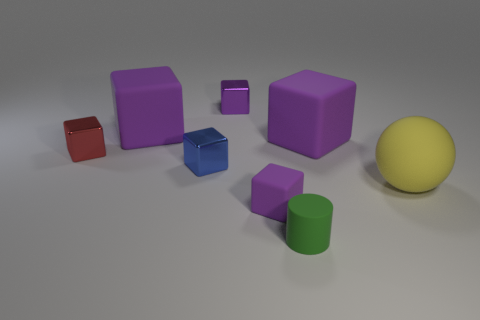There is a rubber block in front of the red metal object; does it have the same color as the big matte cube that is to the left of the matte cylinder?
Keep it short and to the point. Yes. Are there any small blue metal blocks?
Offer a very short reply. Yes. Is there a blue cube that has the same material as the red object?
Your answer should be very brief. Yes. What is the color of the tiny rubber cylinder?
Make the answer very short. Green. The tiny object that is the same color as the small matte block is what shape?
Ensure brevity in your answer.  Cube. What is the color of the rubber block that is the same size as the red object?
Your answer should be compact. Purple. How many matte things are objects or small green objects?
Keep it short and to the point. 5. What number of matte objects are both to the left of the tiny purple metallic cube and in front of the blue metallic thing?
Give a very brief answer. 0. Is there any other thing that has the same shape as the tiny blue metallic thing?
Keep it short and to the point. Yes. How many other objects are the same size as the green thing?
Offer a terse response. 4. 